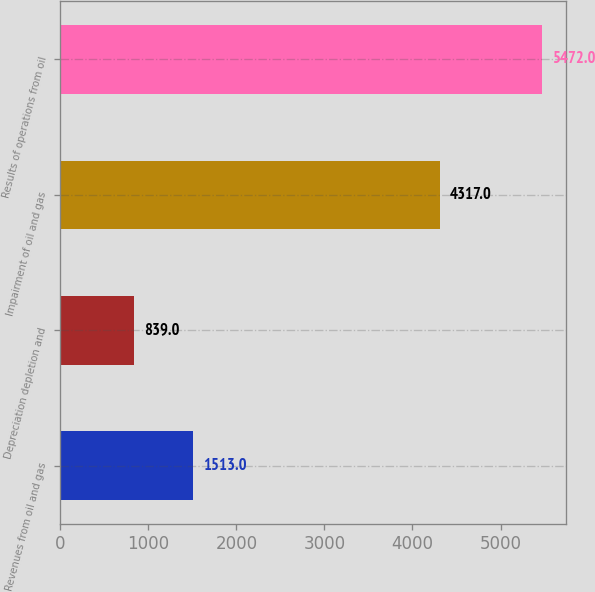Convert chart. <chart><loc_0><loc_0><loc_500><loc_500><bar_chart><fcel>Revenues from oil and gas<fcel>Depreciation depletion and<fcel>Impairment of oil and gas<fcel>Results of operations from oil<nl><fcel>1513<fcel>839<fcel>4317<fcel>5472<nl></chart> 